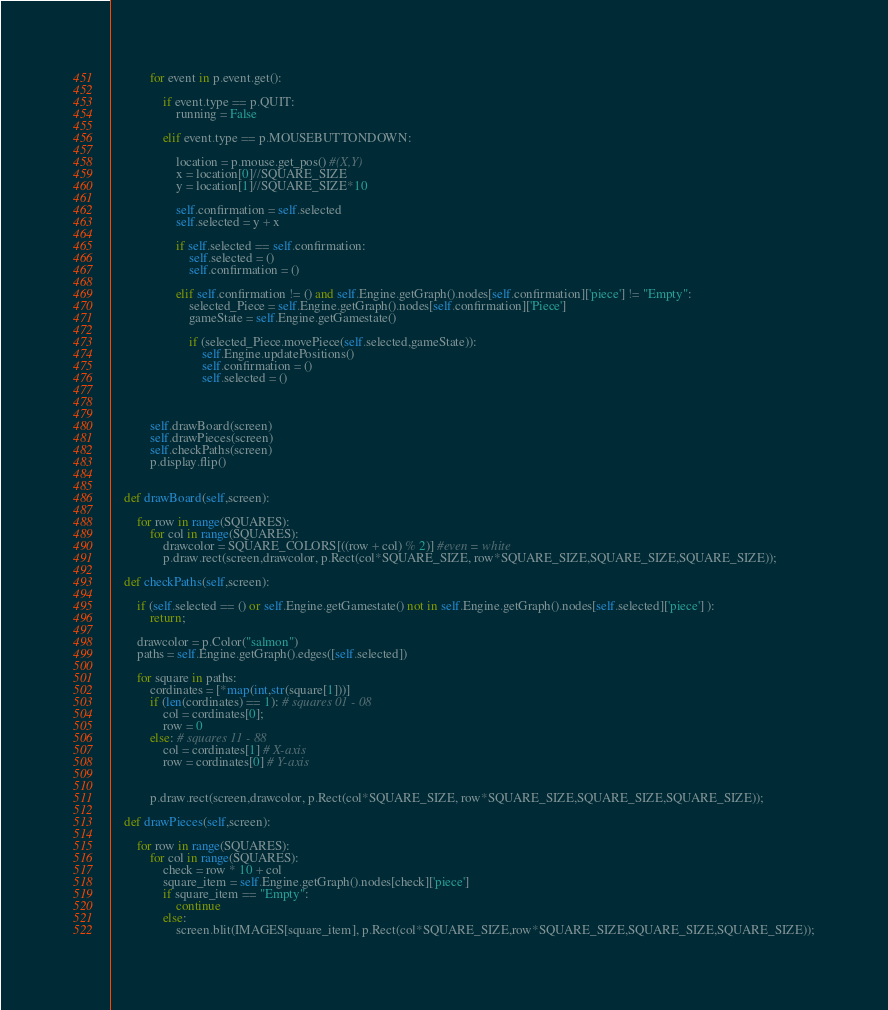<code> <loc_0><loc_0><loc_500><loc_500><_Python_>            for event in p.event.get():
                
                if event.type == p.QUIT:
                    running = False

                elif event.type == p.MOUSEBUTTONDOWN:
                    
                    location = p.mouse.get_pos() #(X,Y)
                    x = location[0]//SQUARE_SIZE
                    y = location[1]//SQUARE_SIZE*10
                    
                    self.confirmation = self.selected
                    self.selected = y + x

                    if self.selected == self.confirmation:
                        self.selected = ()
                        self.confirmation = ()

                    elif self.confirmation != () and self.Engine.getGraph().nodes[self.confirmation]['piece'] != "Empty":
                        selected_Piece = self.Engine.getGraph().nodes[self.confirmation]['Piece']
                        gameState = self.Engine.getGamestate()

                        if (selected_Piece.movePiece(self.selected,gameState)):
                            self.Engine.updatePositions()
                            self.confirmation = ()
                            self.selected = ()
                        
                        
                         
            self.drawBoard(screen)
            self.drawPieces(screen)
            self.checkPaths(screen)
            p.display.flip()
    

    def drawBoard(self,screen):
        
        for row in range(SQUARES):
            for col in range(SQUARES):
                drawcolor = SQUARE_COLORS[((row + col) % 2)] #even = white
                p.draw.rect(screen,drawcolor, p.Rect(col*SQUARE_SIZE, row*SQUARE_SIZE,SQUARE_SIZE,SQUARE_SIZE));

    def checkPaths(self,screen):

        if (self.selected == () or self.Engine.getGamestate() not in self.Engine.getGraph().nodes[self.selected]['piece'] ):
            return;

        drawcolor = p.Color("salmon")
        paths = self.Engine.getGraph().edges([self.selected])
        
        for square in paths:
            cordinates = [*map(int,str(square[1]))]
            if (len(cordinates) == 1): # squares 01 - 08
                col = cordinates[0];
                row = 0
            else: # squares 11 - 88
                col = cordinates[1] # X-axis
                row = cordinates[0] # Y-axis
            
            
            p.draw.rect(screen,drawcolor, p.Rect(col*SQUARE_SIZE, row*SQUARE_SIZE,SQUARE_SIZE,SQUARE_SIZE));

    def drawPieces(self,screen):

        for row in range(SQUARES):
            for col in range(SQUARES):
                check = row * 10 + col
                square_item = self.Engine.getGraph().nodes[check]['piece']
                if square_item == "Empty":
                    continue
                else:
                    screen.blit(IMAGES[square_item], p.Rect(col*SQUARE_SIZE,row*SQUARE_SIZE,SQUARE_SIZE,SQUARE_SIZE));</code> 